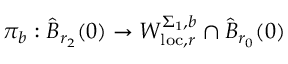<formula> <loc_0><loc_0><loc_500><loc_500>\pi _ { b } \colon \widehat { B } _ { r _ { 2 } } ( 0 ) \to W _ { l o c , r } ^ { \Sigma _ { 1 } , b } \cap \widehat { B } _ { r _ { 0 } } ( 0 )</formula> 